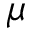Convert formula to latex. <formula><loc_0><loc_0><loc_500><loc_500>\mu</formula> 